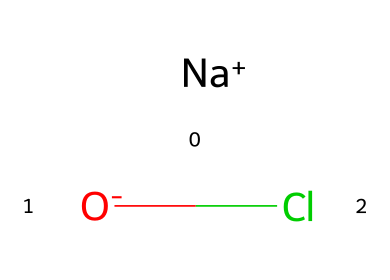What is the central atom in this chemical? The SMILES representation indicates the presence of chlorine (Cl) as the central atom, which is directly associated with the sodium (Na) and oxygen (O) components. Therefore, chlorine serves as the focal point of this structure.
Answer: chlorine How many different elements are present in this compound? Analyzing the SMILES notation reveals three distinct elements: sodium (Na), oxygen (O), and chlorine (Cl). Thus, we can count them to identify the total number of unique elements.
Answer: three What type of ion is sodium in this chemical? In the SMILES structure, sodium (Na) is denoted with a plus sign, indicating that it exists as a cation. This means sodium carries a positive charge, fulfilling the ionic role necessary for this compound’s stability.
Answer: cation What is the oxidation state of chlorine in this compound? Considering the charge balance, sodium contributes a +1 charge, while the oxygen holds a -2 charge (as indicated by the negative sign), making chlorine the balancing ion that must adopt a -1 oxidation state to satisfy overall neutrality.
Answer: -1 What role does chlorine play in this compound? Chlorine acts as a disinfectant, with its presence required for introducing antimicrobial properties. This role is inherent due to chlorine's nature as a halogen, well-known for its effectiveness in killing bacteria and pathogens.
Answer: disinfectant What is the total charge of the compound? The compound's charge can be evaluated by summing the individual charges: sodium is +1, oxygen is -2, and chlorine is neutral in terms of overall compound charge when balanced; hence, the total charge is -1.
Answer: -1 